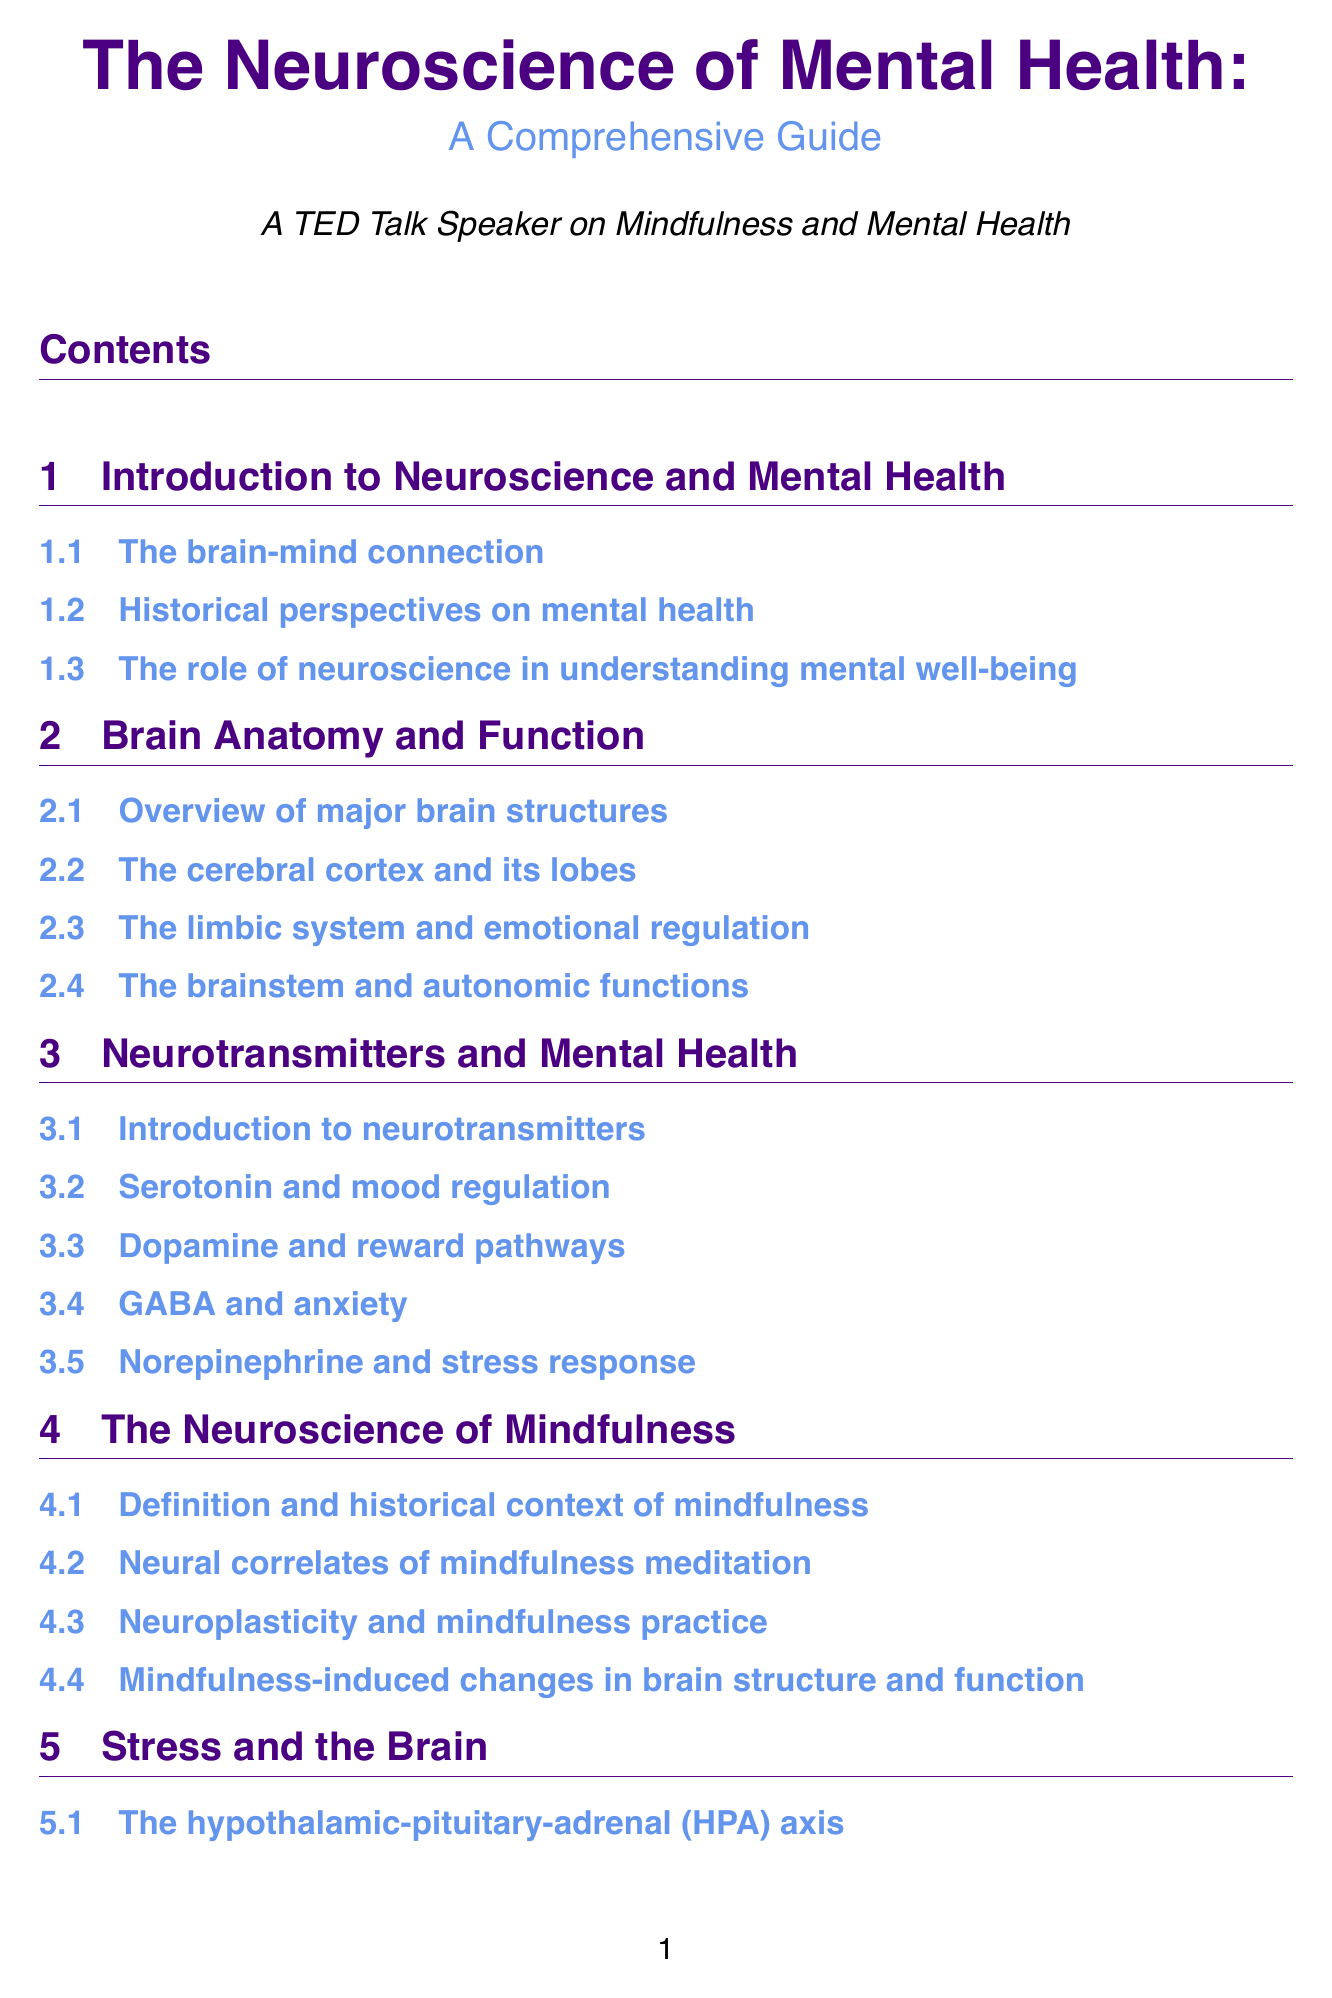What is the title of the manual? The title of the manual is listed at the beginning of the document.
Answer: The Neuroscience of Mental Health: A Comprehensive Guide How many chapters are in the manual? The number of chapters is indicated in the table of contents.
Answer: Ten Which brain structure is associated with emotional regulation? The document specifies brain structures involved in emotional regulation in a section.
Answer: The limbic system What neurotransmitter is linked to anxiety? The manual mentions neurotransmitters in relation to mental health, including anxiety.
Answer: GABA What are the neural correlates of mindfulness meditation? This question requires understanding of how mindfulness is discussed in relation to neuroscience.
Answer: Neural correlates of mindfulness meditation Which axis is crucial for the stress response? The manual describes the HPA axis in relation to stress responses.
Answer: HPA axis What role does neuroplasticity play in building resilience? The document explains neuroplasticity in terms of resilience.
Answer: Building resilience What type of interventions are mentioned for improving sleep quality? The document lists mindfulness-based interventions related to sleep.
Answer: Mindfulness-based interventions What is one recommended resource for understanding mindfulness and the brain? The document includes a section on recommended resources for further reading.
Answer: Mindfulness and the Brain: A Professional Training in the Science and Practice of Meditative Awareness by Daniel J. Siegel How many key concepts are defined in the manual? The key concepts section provides a list of terms related to neuroscience and mental health.
Answer: Ten 